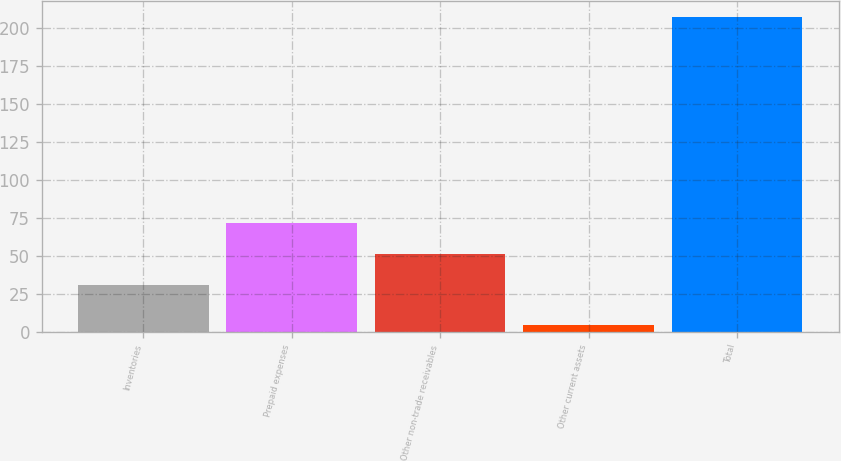Convert chart. <chart><loc_0><loc_0><loc_500><loc_500><bar_chart><fcel>Inventories<fcel>Prepaid expenses<fcel>Other non-trade receivables<fcel>Other current assets<fcel>Total<nl><fcel>31.3<fcel>71.78<fcel>51.54<fcel>5<fcel>207.4<nl></chart> 